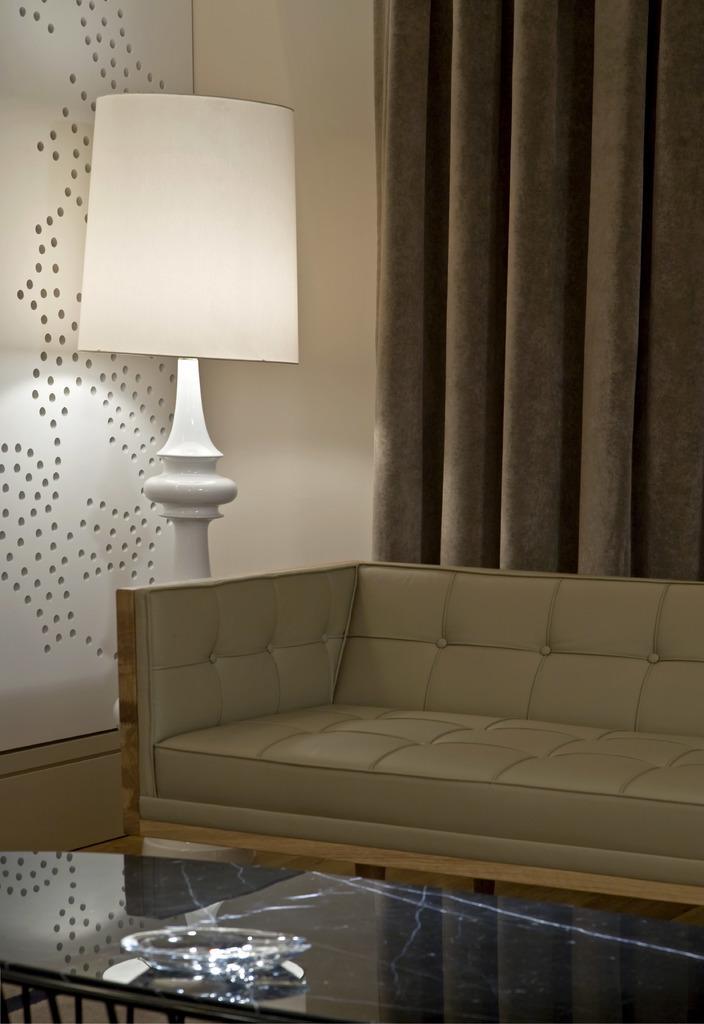Can you describe this image briefly? It is inside a house, it looks like a hall, there is a sofa in front of the sofa there is a table to the left side of the sofa there is a lamp, in the background there is a curtain and a wall beside it. 